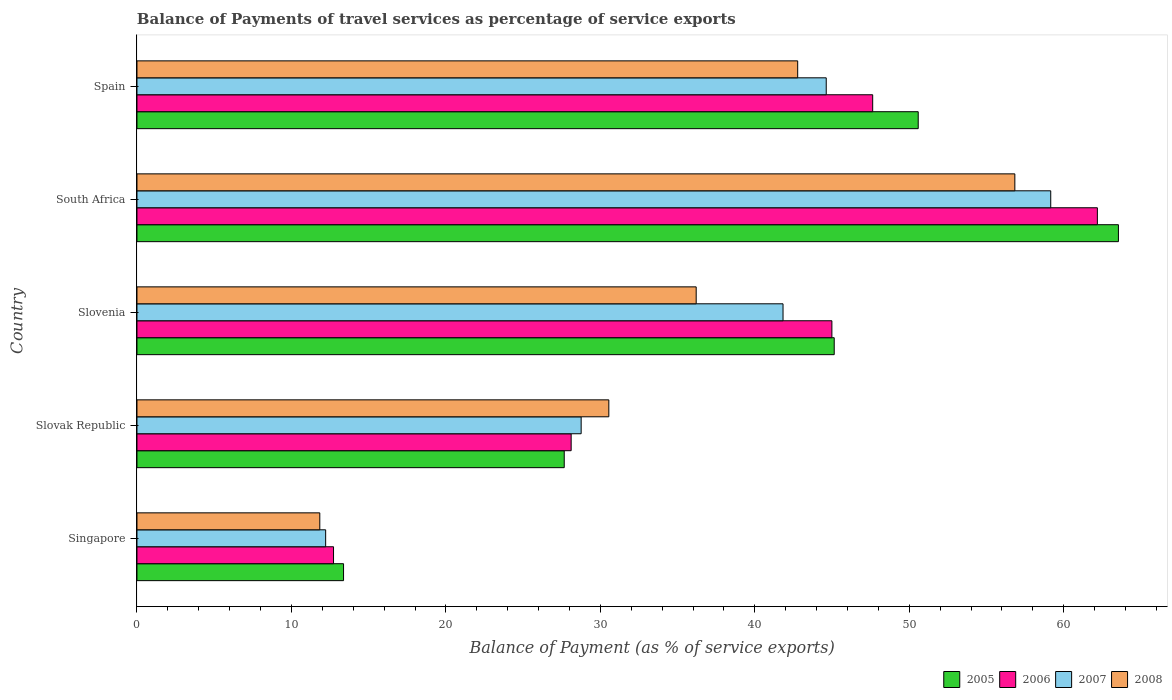How many groups of bars are there?
Your response must be concise. 5. Are the number of bars on each tick of the Y-axis equal?
Offer a very short reply. Yes. What is the label of the 2nd group of bars from the top?
Provide a succinct answer. South Africa. What is the balance of payments of travel services in 2006 in Slovak Republic?
Provide a succinct answer. 28.11. Across all countries, what is the maximum balance of payments of travel services in 2006?
Give a very brief answer. 62.18. Across all countries, what is the minimum balance of payments of travel services in 2005?
Offer a very short reply. 13.37. In which country was the balance of payments of travel services in 2006 maximum?
Your answer should be compact. South Africa. In which country was the balance of payments of travel services in 2007 minimum?
Offer a terse response. Singapore. What is the total balance of payments of travel services in 2006 in the graph?
Your answer should be very brief. 195.63. What is the difference between the balance of payments of travel services in 2005 in Singapore and that in Spain?
Your response must be concise. -37.21. What is the difference between the balance of payments of travel services in 2008 in Slovenia and the balance of payments of travel services in 2005 in Slovak Republic?
Offer a terse response. 8.54. What is the average balance of payments of travel services in 2007 per country?
Provide a succinct answer. 37.32. What is the difference between the balance of payments of travel services in 2006 and balance of payments of travel services in 2007 in Slovenia?
Provide a succinct answer. 3.16. What is the ratio of the balance of payments of travel services in 2005 in Singapore to that in South Africa?
Your response must be concise. 0.21. Is the difference between the balance of payments of travel services in 2006 in Slovak Republic and Spain greater than the difference between the balance of payments of travel services in 2007 in Slovak Republic and Spain?
Your response must be concise. No. What is the difference between the highest and the second highest balance of payments of travel services in 2005?
Give a very brief answer. 12.96. What is the difference between the highest and the lowest balance of payments of travel services in 2008?
Ensure brevity in your answer.  45. What does the 3rd bar from the top in Slovak Republic represents?
Make the answer very short. 2006. What does the 2nd bar from the bottom in Slovak Republic represents?
Your answer should be compact. 2006. Is it the case that in every country, the sum of the balance of payments of travel services in 2005 and balance of payments of travel services in 2007 is greater than the balance of payments of travel services in 2008?
Your response must be concise. Yes. How many bars are there?
Your response must be concise. 20. How many countries are there in the graph?
Make the answer very short. 5. Does the graph contain grids?
Make the answer very short. No. Where does the legend appear in the graph?
Make the answer very short. Bottom right. How are the legend labels stacked?
Your answer should be very brief. Horizontal. What is the title of the graph?
Your response must be concise. Balance of Payments of travel services as percentage of service exports. What is the label or title of the X-axis?
Provide a short and direct response. Balance of Payment (as % of service exports). What is the Balance of Payment (as % of service exports) of 2005 in Singapore?
Provide a succinct answer. 13.37. What is the Balance of Payment (as % of service exports) in 2006 in Singapore?
Provide a succinct answer. 12.73. What is the Balance of Payment (as % of service exports) in 2007 in Singapore?
Make the answer very short. 12.22. What is the Balance of Payment (as % of service exports) in 2008 in Singapore?
Offer a very short reply. 11.84. What is the Balance of Payment (as % of service exports) of 2005 in Slovak Republic?
Make the answer very short. 27.66. What is the Balance of Payment (as % of service exports) of 2006 in Slovak Republic?
Your answer should be compact. 28.11. What is the Balance of Payment (as % of service exports) of 2007 in Slovak Republic?
Offer a terse response. 28.76. What is the Balance of Payment (as % of service exports) in 2008 in Slovak Republic?
Provide a succinct answer. 30.55. What is the Balance of Payment (as % of service exports) of 2005 in Slovenia?
Offer a terse response. 45.14. What is the Balance of Payment (as % of service exports) in 2006 in Slovenia?
Keep it short and to the point. 44.99. What is the Balance of Payment (as % of service exports) of 2007 in Slovenia?
Offer a terse response. 41.83. What is the Balance of Payment (as % of service exports) of 2008 in Slovenia?
Make the answer very short. 36.2. What is the Balance of Payment (as % of service exports) of 2005 in South Africa?
Ensure brevity in your answer.  63.54. What is the Balance of Payment (as % of service exports) in 2006 in South Africa?
Provide a succinct answer. 62.18. What is the Balance of Payment (as % of service exports) in 2007 in South Africa?
Offer a terse response. 59.16. What is the Balance of Payment (as % of service exports) in 2008 in South Africa?
Keep it short and to the point. 56.83. What is the Balance of Payment (as % of service exports) in 2005 in Spain?
Your answer should be very brief. 50.58. What is the Balance of Payment (as % of service exports) in 2006 in Spain?
Your response must be concise. 47.63. What is the Balance of Payment (as % of service exports) in 2007 in Spain?
Offer a terse response. 44.62. What is the Balance of Payment (as % of service exports) in 2008 in Spain?
Your answer should be compact. 42.78. Across all countries, what is the maximum Balance of Payment (as % of service exports) of 2005?
Offer a very short reply. 63.54. Across all countries, what is the maximum Balance of Payment (as % of service exports) in 2006?
Offer a very short reply. 62.18. Across all countries, what is the maximum Balance of Payment (as % of service exports) in 2007?
Keep it short and to the point. 59.16. Across all countries, what is the maximum Balance of Payment (as % of service exports) of 2008?
Ensure brevity in your answer.  56.83. Across all countries, what is the minimum Balance of Payment (as % of service exports) of 2005?
Make the answer very short. 13.37. Across all countries, what is the minimum Balance of Payment (as % of service exports) in 2006?
Your response must be concise. 12.73. Across all countries, what is the minimum Balance of Payment (as % of service exports) in 2007?
Your response must be concise. 12.22. Across all countries, what is the minimum Balance of Payment (as % of service exports) of 2008?
Your answer should be compact. 11.84. What is the total Balance of Payment (as % of service exports) in 2005 in the graph?
Offer a terse response. 200.3. What is the total Balance of Payment (as % of service exports) in 2006 in the graph?
Offer a very short reply. 195.63. What is the total Balance of Payment (as % of service exports) of 2007 in the graph?
Provide a succinct answer. 186.58. What is the total Balance of Payment (as % of service exports) in 2008 in the graph?
Provide a short and direct response. 178.2. What is the difference between the Balance of Payment (as % of service exports) of 2005 in Singapore and that in Slovak Republic?
Offer a terse response. -14.29. What is the difference between the Balance of Payment (as % of service exports) in 2006 in Singapore and that in Slovak Republic?
Offer a terse response. -15.38. What is the difference between the Balance of Payment (as % of service exports) in 2007 in Singapore and that in Slovak Republic?
Give a very brief answer. -16.54. What is the difference between the Balance of Payment (as % of service exports) in 2008 in Singapore and that in Slovak Republic?
Keep it short and to the point. -18.71. What is the difference between the Balance of Payment (as % of service exports) in 2005 in Singapore and that in Slovenia?
Provide a succinct answer. -31.77. What is the difference between the Balance of Payment (as % of service exports) of 2006 in Singapore and that in Slovenia?
Make the answer very short. -32.26. What is the difference between the Balance of Payment (as % of service exports) in 2007 in Singapore and that in Slovenia?
Make the answer very short. -29.61. What is the difference between the Balance of Payment (as % of service exports) in 2008 in Singapore and that in Slovenia?
Your answer should be very brief. -24.37. What is the difference between the Balance of Payment (as % of service exports) in 2005 in Singapore and that in South Africa?
Give a very brief answer. -50.17. What is the difference between the Balance of Payment (as % of service exports) of 2006 in Singapore and that in South Africa?
Offer a very short reply. -49.45. What is the difference between the Balance of Payment (as % of service exports) in 2007 in Singapore and that in South Africa?
Your response must be concise. -46.94. What is the difference between the Balance of Payment (as % of service exports) in 2008 in Singapore and that in South Africa?
Ensure brevity in your answer.  -45. What is the difference between the Balance of Payment (as % of service exports) in 2005 in Singapore and that in Spain?
Offer a very short reply. -37.21. What is the difference between the Balance of Payment (as % of service exports) of 2006 in Singapore and that in Spain?
Your response must be concise. -34.91. What is the difference between the Balance of Payment (as % of service exports) of 2007 in Singapore and that in Spain?
Your answer should be compact. -32.41. What is the difference between the Balance of Payment (as % of service exports) of 2008 in Singapore and that in Spain?
Give a very brief answer. -30.94. What is the difference between the Balance of Payment (as % of service exports) in 2005 in Slovak Republic and that in Slovenia?
Provide a short and direct response. -17.48. What is the difference between the Balance of Payment (as % of service exports) of 2006 in Slovak Republic and that in Slovenia?
Offer a terse response. -16.88. What is the difference between the Balance of Payment (as % of service exports) of 2007 in Slovak Republic and that in Slovenia?
Provide a succinct answer. -13.07. What is the difference between the Balance of Payment (as % of service exports) of 2008 in Slovak Republic and that in Slovenia?
Offer a terse response. -5.66. What is the difference between the Balance of Payment (as % of service exports) in 2005 in Slovak Republic and that in South Africa?
Your answer should be compact. -35.88. What is the difference between the Balance of Payment (as % of service exports) in 2006 in Slovak Republic and that in South Africa?
Offer a terse response. -34.07. What is the difference between the Balance of Payment (as % of service exports) in 2007 in Slovak Republic and that in South Africa?
Provide a succinct answer. -30.4. What is the difference between the Balance of Payment (as % of service exports) of 2008 in Slovak Republic and that in South Africa?
Provide a succinct answer. -26.29. What is the difference between the Balance of Payment (as % of service exports) in 2005 in Slovak Republic and that in Spain?
Your response must be concise. -22.92. What is the difference between the Balance of Payment (as % of service exports) of 2006 in Slovak Republic and that in Spain?
Your answer should be very brief. -19.52. What is the difference between the Balance of Payment (as % of service exports) of 2007 in Slovak Republic and that in Spain?
Provide a succinct answer. -15.87. What is the difference between the Balance of Payment (as % of service exports) in 2008 in Slovak Republic and that in Spain?
Provide a short and direct response. -12.23. What is the difference between the Balance of Payment (as % of service exports) of 2005 in Slovenia and that in South Africa?
Provide a short and direct response. -18.4. What is the difference between the Balance of Payment (as % of service exports) in 2006 in Slovenia and that in South Africa?
Your answer should be very brief. -17.19. What is the difference between the Balance of Payment (as % of service exports) in 2007 in Slovenia and that in South Africa?
Provide a short and direct response. -17.33. What is the difference between the Balance of Payment (as % of service exports) of 2008 in Slovenia and that in South Africa?
Offer a very short reply. -20.63. What is the difference between the Balance of Payment (as % of service exports) of 2005 in Slovenia and that in Spain?
Offer a very short reply. -5.44. What is the difference between the Balance of Payment (as % of service exports) in 2006 in Slovenia and that in Spain?
Your answer should be very brief. -2.64. What is the difference between the Balance of Payment (as % of service exports) of 2007 in Slovenia and that in Spain?
Give a very brief answer. -2.8. What is the difference between the Balance of Payment (as % of service exports) of 2008 in Slovenia and that in Spain?
Offer a terse response. -6.57. What is the difference between the Balance of Payment (as % of service exports) of 2005 in South Africa and that in Spain?
Offer a terse response. 12.96. What is the difference between the Balance of Payment (as % of service exports) in 2006 in South Africa and that in Spain?
Your response must be concise. 14.55. What is the difference between the Balance of Payment (as % of service exports) in 2007 in South Africa and that in Spain?
Your response must be concise. 14.53. What is the difference between the Balance of Payment (as % of service exports) in 2008 in South Africa and that in Spain?
Keep it short and to the point. 14.06. What is the difference between the Balance of Payment (as % of service exports) of 2005 in Singapore and the Balance of Payment (as % of service exports) of 2006 in Slovak Republic?
Make the answer very short. -14.74. What is the difference between the Balance of Payment (as % of service exports) in 2005 in Singapore and the Balance of Payment (as % of service exports) in 2007 in Slovak Republic?
Your answer should be compact. -15.38. What is the difference between the Balance of Payment (as % of service exports) in 2005 in Singapore and the Balance of Payment (as % of service exports) in 2008 in Slovak Republic?
Your answer should be compact. -17.18. What is the difference between the Balance of Payment (as % of service exports) of 2006 in Singapore and the Balance of Payment (as % of service exports) of 2007 in Slovak Republic?
Provide a short and direct response. -16.03. What is the difference between the Balance of Payment (as % of service exports) in 2006 in Singapore and the Balance of Payment (as % of service exports) in 2008 in Slovak Republic?
Your answer should be compact. -17.82. What is the difference between the Balance of Payment (as % of service exports) of 2007 in Singapore and the Balance of Payment (as % of service exports) of 2008 in Slovak Republic?
Your response must be concise. -18.33. What is the difference between the Balance of Payment (as % of service exports) of 2005 in Singapore and the Balance of Payment (as % of service exports) of 2006 in Slovenia?
Make the answer very short. -31.62. What is the difference between the Balance of Payment (as % of service exports) in 2005 in Singapore and the Balance of Payment (as % of service exports) in 2007 in Slovenia?
Provide a succinct answer. -28.45. What is the difference between the Balance of Payment (as % of service exports) in 2005 in Singapore and the Balance of Payment (as % of service exports) in 2008 in Slovenia?
Your answer should be compact. -22.83. What is the difference between the Balance of Payment (as % of service exports) of 2006 in Singapore and the Balance of Payment (as % of service exports) of 2007 in Slovenia?
Your answer should be compact. -29.1. What is the difference between the Balance of Payment (as % of service exports) in 2006 in Singapore and the Balance of Payment (as % of service exports) in 2008 in Slovenia?
Offer a terse response. -23.48. What is the difference between the Balance of Payment (as % of service exports) in 2007 in Singapore and the Balance of Payment (as % of service exports) in 2008 in Slovenia?
Provide a succinct answer. -23.99. What is the difference between the Balance of Payment (as % of service exports) of 2005 in Singapore and the Balance of Payment (as % of service exports) of 2006 in South Africa?
Offer a terse response. -48.8. What is the difference between the Balance of Payment (as % of service exports) of 2005 in Singapore and the Balance of Payment (as % of service exports) of 2007 in South Africa?
Offer a terse response. -45.78. What is the difference between the Balance of Payment (as % of service exports) in 2005 in Singapore and the Balance of Payment (as % of service exports) in 2008 in South Africa?
Ensure brevity in your answer.  -43.46. What is the difference between the Balance of Payment (as % of service exports) in 2006 in Singapore and the Balance of Payment (as % of service exports) in 2007 in South Africa?
Provide a succinct answer. -46.43. What is the difference between the Balance of Payment (as % of service exports) in 2006 in Singapore and the Balance of Payment (as % of service exports) in 2008 in South Africa?
Your answer should be compact. -44.11. What is the difference between the Balance of Payment (as % of service exports) in 2007 in Singapore and the Balance of Payment (as % of service exports) in 2008 in South Africa?
Provide a succinct answer. -44.62. What is the difference between the Balance of Payment (as % of service exports) of 2005 in Singapore and the Balance of Payment (as % of service exports) of 2006 in Spain?
Offer a very short reply. -34.26. What is the difference between the Balance of Payment (as % of service exports) of 2005 in Singapore and the Balance of Payment (as % of service exports) of 2007 in Spain?
Ensure brevity in your answer.  -31.25. What is the difference between the Balance of Payment (as % of service exports) of 2005 in Singapore and the Balance of Payment (as % of service exports) of 2008 in Spain?
Make the answer very short. -29.4. What is the difference between the Balance of Payment (as % of service exports) in 2006 in Singapore and the Balance of Payment (as % of service exports) in 2007 in Spain?
Make the answer very short. -31.9. What is the difference between the Balance of Payment (as % of service exports) of 2006 in Singapore and the Balance of Payment (as % of service exports) of 2008 in Spain?
Offer a very short reply. -30.05. What is the difference between the Balance of Payment (as % of service exports) of 2007 in Singapore and the Balance of Payment (as % of service exports) of 2008 in Spain?
Offer a terse response. -30.56. What is the difference between the Balance of Payment (as % of service exports) of 2005 in Slovak Republic and the Balance of Payment (as % of service exports) of 2006 in Slovenia?
Make the answer very short. -17.33. What is the difference between the Balance of Payment (as % of service exports) in 2005 in Slovak Republic and the Balance of Payment (as % of service exports) in 2007 in Slovenia?
Offer a very short reply. -14.16. What is the difference between the Balance of Payment (as % of service exports) of 2005 in Slovak Republic and the Balance of Payment (as % of service exports) of 2008 in Slovenia?
Your answer should be very brief. -8.54. What is the difference between the Balance of Payment (as % of service exports) of 2006 in Slovak Republic and the Balance of Payment (as % of service exports) of 2007 in Slovenia?
Provide a succinct answer. -13.72. What is the difference between the Balance of Payment (as % of service exports) of 2006 in Slovak Republic and the Balance of Payment (as % of service exports) of 2008 in Slovenia?
Your response must be concise. -8.1. What is the difference between the Balance of Payment (as % of service exports) in 2007 in Slovak Republic and the Balance of Payment (as % of service exports) in 2008 in Slovenia?
Provide a short and direct response. -7.45. What is the difference between the Balance of Payment (as % of service exports) of 2005 in Slovak Republic and the Balance of Payment (as % of service exports) of 2006 in South Africa?
Your answer should be very brief. -34.52. What is the difference between the Balance of Payment (as % of service exports) in 2005 in Slovak Republic and the Balance of Payment (as % of service exports) in 2007 in South Africa?
Keep it short and to the point. -31.5. What is the difference between the Balance of Payment (as % of service exports) in 2005 in Slovak Republic and the Balance of Payment (as % of service exports) in 2008 in South Africa?
Your answer should be compact. -29.17. What is the difference between the Balance of Payment (as % of service exports) in 2006 in Slovak Republic and the Balance of Payment (as % of service exports) in 2007 in South Africa?
Offer a terse response. -31.05. What is the difference between the Balance of Payment (as % of service exports) of 2006 in Slovak Republic and the Balance of Payment (as % of service exports) of 2008 in South Africa?
Your response must be concise. -28.73. What is the difference between the Balance of Payment (as % of service exports) in 2007 in Slovak Republic and the Balance of Payment (as % of service exports) in 2008 in South Africa?
Your response must be concise. -28.08. What is the difference between the Balance of Payment (as % of service exports) in 2005 in Slovak Republic and the Balance of Payment (as % of service exports) in 2006 in Spain?
Your response must be concise. -19.97. What is the difference between the Balance of Payment (as % of service exports) in 2005 in Slovak Republic and the Balance of Payment (as % of service exports) in 2007 in Spain?
Make the answer very short. -16.96. What is the difference between the Balance of Payment (as % of service exports) of 2005 in Slovak Republic and the Balance of Payment (as % of service exports) of 2008 in Spain?
Provide a succinct answer. -15.11. What is the difference between the Balance of Payment (as % of service exports) of 2006 in Slovak Republic and the Balance of Payment (as % of service exports) of 2007 in Spain?
Give a very brief answer. -16.51. What is the difference between the Balance of Payment (as % of service exports) of 2006 in Slovak Republic and the Balance of Payment (as % of service exports) of 2008 in Spain?
Offer a terse response. -14.67. What is the difference between the Balance of Payment (as % of service exports) in 2007 in Slovak Republic and the Balance of Payment (as % of service exports) in 2008 in Spain?
Give a very brief answer. -14.02. What is the difference between the Balance of Payment (as % of service exports) in 2005 in Slovenia and the Balance of Payment (as % of service exports) in 2006 in South Africa?
Offer a terse response. -17.04. What is the difference between the Balance of Payment (as % of service exports) in 2005 in Slovenia and the Balance of Payment (as % of service exports) in 2007 in South Africa?
Your response must be concise. -14.02. What is the difference between the Balance of Payment (as % of service exports) of 2005 in Slovenia and the Balance of Payment (as % of service exports) of 2008 in South Africa?
Give a very brief answer. -11.69. What is the difference between the Balance of Payment (as % of service exports) of 2006 in Slovenia and the Balance of Payment (as % of service exports) of 2007 in South Africa?
Give a very brief answer. -14.17. What is the difference between the Balance of Payment (as % of service exports) of 2006 in Slovenia and the Balance of Payment (as % of service exports) of 2008 in South Africa?
Your response must be concise. -11.84. What is the difference between the Balance of Payment (as % of service exports) in 2007 in Slovenia and the Balance of Payment (as % of service exports) in 2008 in South Africa?
Provide a succinct answer. -15.01. What is the difference between the Balance of Payment (as % of service exports) of 2005 in Slovenia and the Balance of Payment (as % of service exports) of 2006 in Spain?
Provide a short and direct response. -2.49. What is the difference between the Balance of Payment (as % of service exports) of 2005 in Slovenia and the Balance of Payment (as % of service exports) of 2007 in Spain?
Give a very brief answer. 0.52. What is the difference between the Balance of Payment (as % of service exports) in 2005 in Slovenia and the Balance of Payment (as % of service exports) in 2008 in Spain?
Your answer should be compact. 2.37. What is the difference between the Balance of Payment (as % of service exports) of 2006 in Slovenia and the Balance of Payment (as % of service exports) of 2007 in Spain?
Offer a very short reply. 0.37. What is the difference between the Balance of Payment (as % of service exports) in 2006 in Slovenia and the Balance of Payment (as % of service exports) in 2008 in Spain?
Your answer should be compact. 2.21. What is the difference between the Balance of Payment (as % of service exports) in 2007 in Slovenia and the Balance of Payment (as % of service exports) in 2008 in Spain?
Offer a very short reply. -0.95. What is the difference between the Balance of Payment (as % of service exports) in 2005 in South Africa and the Balance of Payment (as % of service exports) in 2006 in Spain?
Your answer should be very brief. 15.91. What is the difference between the Balance of Payment (as % of service exports) in 2005 in South Africa and the Balance of Payment (as % of service exports) in 2007 in Spain?
Offer a terse response. 18.92. What is the difference between the Balance of Payment (as % of service exports) in 2005 in South Africa and the Balance of Payment (as % of service exports) in 2008 in Spain?
Your answer should be very brief. 20.76. What is the difference between the Balance of Payment (as % of service exports) of 2006 in South Africa and the Balance of Payment (as % of service exports) of 2007 in Spain?
Ensure brevity in your answer.  17.55. What is the difference between the Balance of Payment (as % of service exports) of 2006 in South Africa and the Balance of Payment (as % of service exports) of 2008 in Spain?
Keep it short and to the point. 19.4. What is the difference between the Balance of Payment (as % of service exports) of 2007 in South Africa and the Balance of Payment (as % of service exports) of 2008 in Spain?
Your response must be concise. 16.38. What is the average Balance of Payment (as % of service exports) of 2005 per country?
Provide a short and direct response. 40.06. What is the average Balance of Payment (as % of service exports) of 2006 per country?
Offer a very short reply. 39.13. What is the average Balance of Payment (as % of service exports) of 2007 per country?
Provide a succinct answer. 37.32. What is the average Balance of Payment (as % of service exports) of 2008 per country?
Your answer should be very brief. 35.64. What is the difference between the Balance of Payment (as % of service exports) in 2005 and Balance of Payment (as % of service exports) in 2006 in Singapore?
Keep it short and to the point. 0.65. What is the difference between the Balance of Payment (as % of service exports) in 2005 and Balance of Payment (as % of service exports) in 2007 in Singapore?
Provide a short and direct response. 1.16. What is the difference between the Balance of Payment (as % of service exports) of 2005 and Balance of Payment (as % of service exports) of 2008 in Singapore?
Provide a short and direct response. 1.54. What is the difference between the Balance of Payment (as % of service exports) in 2006 and Balance of Payment (as % of service exports) in 2007 in Singapore?
Offer a very short reply. 0.51. What is the difference between the Balance of Payment (as % of service exports) in 2007 and Balance of Payment (as % of service exports) in 2008 in Singapore?
Make the answer very short. 0.38. What is the difference between the Balance of Payment (as % of service exports) in 2005 and Balance of Payment (as % of service exports) in 2006 in Slovak Republic?
Make the answer very short. -0.45. What is the difference between the Balance of Payment (as % of service exports) of 2005 and Balance of Payment (as % of service exports) of 2007 in Slovak Republic?
Your response must be concise. -1.1. What is the difference between the Balance of Payment (as % of service exports) in 2005 and Balance of Payment (as % of service exports) in 2008 in Slovak Republic?
Give a very brief answer. -2.89. What is the difference between the Balance of Payment (as % of service exports) in 2006 and Balance of Payment (as % of service exports) in 2007 in Slovak Republic?
Provide a succinct answer. -0.65. What is the difference between the Balance of Payment (as % of service exports) of 2006 and Balance of Payment (as % of service exports) of 2008 in Slovak Republic?
Make the answer very short. -2.44. What is the difference between the Balance of Payment (as % of service exports) in 2007 and Balance of Payment (as % of service exports) in 2008 in Slovak Republic?
Your answer should be compact. -1.79. What is the difference between the Balance of Payment (as % of service exports) in 2005 and Balance of Payment (as % of service exports) in 2006 in Slovenia?
Your answer should be very brief. 0.15. What is the difference between the Balance of Payment (as % of service exports) in 2005 and Balance of Payment (as % of service exports) in 2007 in Slovenia?
Offer a terse response. 3.31. What is the difference between the Balance of Payment (as % of service exports) in 2005 and Balance of Payment (as % of service exports) in 2008 in Slovenia?
Offer a terse response. 8.94. What is the difference between the Balance of Payment (as % of service exports) in 2006 and Balance of Payment (as % of service exports) in 2007 in Slovenia?
Provide a succinct answer. 3.16. What is the difference between the Balance of Payment (as % of service exports) of 2006 and Balance of Payment (as % of service exports) of 2008 in Slovenia?
Offer a very short reply. 8.79. What is the difference between the Balance of Payment (as % of service exports) of 2007 and Balance of Payment (as % of service exports) of 2008 in Slovenia?
Your answer should be very brief. 5.62. What is the difference between the Balance of Payment (as % of service exports) of 2005 and Balance of Payment (as % of service exports) of 2006 in South Africa?
Offer a very short reply. 1.36. What is the difference between the Balance of Payment (as % of service exports) of 2005 and Balance of Payment (as % of service exports) of 2007 in South Africa?
Offer a very short reply. 4.38. What is the difference between the Balance of Payment (as % of service exports) in 2005 and Balance of Payment (as % of service exports) in 2008 in South Africa?
Your response must be concise. 6.71. What is the difference between the Balance of Payment (as % of service exports) of 2006 and Balance of Payment (as % of service exports) of 2007 in South Africa?
Provide a short and direct response. 3.02. What is the difference between the Balance of Payment (as % of service exports) in 2006 and Balance of Payment (as % of service exports) in 2008 in South Africa?
Keep it short and to the point. 5.34. What is the difference between the Balance of Payment (as % of service exports) of 2007 and Balance of Payment (as % of service exports) of 2008 in South Africa?
Your response must be concise. 2.32. What is the difference between the Balance of Payment (as % of service exports) of 2005 and Balance of Payment (as % of service exports) of 2006 in Spain?
Your answer should be very brief. 2.95. What is the difference between the Balance of Payment (as % of service exports) in 2005 and Balance of Payment (as % of service exports) in 2007 in Spain?
Your answer should be very brief. 5.96. What is the difference between the Balance of Payment (as % of service exports) in 2005 and Balance of Payment (as % of service exports) in 2008 in Spain?
Keep it short and to the point. 7.8. What is the difference between the Balance of Payment (as % of service exports) in 2006 and Balance of Payment (as % of service exports) in 2007 in Spain?
Keep it short and to the point. 3.01. What is the difference between the Balance of Payment (as % of service exports) of 2006 and Balance of Payment (as % of service exports) of 2008 in Spain?
Provide a succinct answer. 4.86. What is the difference between the Balance of Payment (as % of service exports) in 2007 and Balance of Payment (as % of service exports) in 2008 in Spain?
Offer a very short reply. 1.85. What is the ratio of the Balance of Payment (as % of service exports) in 2005 in Singapore to that in Slovak Republic?
Make the answer very short. 0.48. What is the ratio of the Balance of Payment (as % of service exports) of 2006 in Singapore to that in Slovak Republic?
Offer a terse response. 0.45. What is the ratio of the Balance of Payment (as % of service exports) in 2007 in Singapore to that in Slovak Republic?
Offer a very short reply. 0.42. What is the ratio of the Balance of Payment (as % of service exports) in 2008 in Singapore to that in Slovak Republic?
Offer a terse response. 0.39. What is the ratio of the Balance of Payment (as % of service exports) of 2005 in Singapore to that in Slovenia?
Your answer should be compact. 0.3. What is the ratio of the Balance of Payment (as % of service exports) in 2006 in Singapore to that in Slovenia?
Give a very brief answer. 0.28. What is the ratio of the Balance of Payment (as % of service exports) in 2007 in Singapore to that in Slovenia?
Ensure brevity in your answer.  0.29. What is the ratio of the Balance of Payment (as % of service exports) in 2008 in Singapore to that in Slovenia?
Keep it short and to the point. 0.33. What is the ratio of the Balance of Payment (as % of service exports) in 2005 in Singapore to that in South Africa?
Your answer should be very brief. 0.21. What is the ratio of the Balance of Payment (as % of service exports) of 2006 in Singapore to that in South Africa?
Make the answer very short. 0.2. What is the ratio of the Balance of Payment (as % of service exports) of 2007 in Singapore to that in South Africa?
Your answer should be very brief. 0.21. What is the ratio of the Balance of Payment (as % of service exports) in 2008 in Singapore to that in South Africa?
Keep it short and to the point. 0.21. What is the ratio of the Balance of Payment (as % of service exports) in 2005 in Singapore to that in Spain?
Offer a terse response. 0.26. What is the ratio of the Balance of Payment (as % of service exports) in 2006 in Singapore to that in Spain?
Keep it short and to the point. 0.27. What is the ratio of the Balance of Payment (as % of service exports) of 2007 in Singapore to that in Spain?
Keep it short and to the point. 0.27. What is the ratio of the Balance of Payment (as % of service exports) in 2008 in Singapore to that in Spain?
Offer a very short reply. 0.28. What is the ratio of the Balance of Payment (as % of service exports) of 2005 in Slovak Republic to that in Slovenia?
Provide a short and direct response. 0.61. What is the ratio of the Balance of Payment (as % of service exports) in 2006 in Slovak Republic to that in Slovenia?
Offer a very short reply. 0.62. What is the ratio of the Balance of Payment (as % of service exports) in 2007 in Slovak Republic to that in Slovenia?
Give a very brief answer. 0.69. What is the ratio of the Balance of Payment (as % of service exports) in 2008 in Slovak Republic to that in Slovenia?
Provide a succinct answer. 0.84. What is the ratio of the Balance of Payment (as % of service exports) of 2005 in Slovak Republic to that in South Africa?
Give a very brief answer. 0.44. What is the ratio of the Balance of Payment (as % of service exports) in 2006 in Slovak Republic to that in South Africa?
Your response must be concise. 0.45. What is the ratio of the Balance of Payment (as % of service exports) in 2007 in Slovak Republic to that in South Africa?
Your answer should be compact. 0.49. What is the ratio of the Balance of Payment (as % of service exports) of 2008 in Slovak Republic to that in South Africa?
Your response must be concise. 0.54. What is the ratio of the Balance of Payment (as % of service exports) of 2005 in Slovak Republic to that in Spain?
Your answer should be compact. 0.55. What is the ratio of the Balance of Payment (as % of service exports) of 2006 in Slovak Republic to that in Spain?
Your answer should be compact. 0.59. What is the ratio of the Balance of Payment (as % of service exports) in 2007 in Slovak Republic to that in Spain?
Give a very brief answer. 0.64. What is the ratio of the Balance of Payment (as % of service exports) of 2008 in Slovak Republic to that in Spain?
Offer a terse response. 0.71. What is the ratio of the Balance of Payment (as % of service exports) of 2005 in Slovenia to that in South Africa?
Provide a succinct answer. 0.71. What is the ratio of the Balance of Payment (as % of service exports) in 2006 in Slovenia to that in South Africa?
Give a very brief answer. 0.72. What is the ratio of the Balance of Payment (as % of service exports) of 2007 in Slovenia to that in South Africa?
Give a very brief answer. 0.71. What is the ratio of the Balance of Payment (as % of service exports) in 2008 in Slovenia to that in South Africa?
Make the answer very short. 0.64. What is the ratio of the Balance of Payment (as % of service exports) of 2005 in Slovenia to that in Spain?
Your answer should be very brief. 0.89. What is the ratio of the Balance of Payment (as % of service exports) in 2006 in Slovenia to that in Spain?
Offer a terse response. 0.94. What is the ratio of the Balance of Payment (as % of service exports) in 2007 in Slovenia to that in Spain?
Provide a short and direct response. 0.94. What is the ratio of the Balance of Payment (as % of service exports) of 2008 in Slovenia to that in Spain?
Your response must be concise. 0.85. What is the ratio of the Balance of Payment (as % of service exports) in 2005 in South Africa to that in Spain?
Provide a short and direct response. 1.26. What is the ratio of the Balance of Payment (as % of service exports) in 2006 in South Africa to that in Spain?
Make the answer very short. 1.31. What is the ratio of the Balance of Payment (as % of service exports) in 2007 in South Africa to that in Spain?
Your answer should be compact. 1.33. What is the ratio of the Balance of Payment (as % of service exports) of 2008 in South Africa to that in Spain?
Your answer should be compact. 1.33. What is the difference between the highest and the second highest Balance of Payment (as % of service exports) of 2005?
Keep it short and to the point. 12.96. What is the difference between the highest and the second highest Balance of Payment (as % of service exports) in 2006?
Your response must be concise. 14.55. What is the difference between the highest and the second highest Balance of Payment (as % of service exports) in 2007?
Provide a succinct answer. 14.53. What is the difference between the highest and the second highest Balance of Payment (as % of service exports) in 2008?
Your answer should be compact. 14.06. What is the difference between the highest and the lowest Balance of Payment (as % of service exports) of 2005?
Keep it short and to the point. 50.17. What is the difference between the highest and the lowest Balance of Payment (as % of service exports) in 2006?
Your answer should be very brief. 49.45. What is the difference between the highest and the lowest Balance of Payment (as % of service exports) in 2007?
Your response must be concise. 46.94. What is the difference between the highest and the lowest Balance of Payment (as % of service exports) of 2008?
Ensure brevity in your answer.  45. 